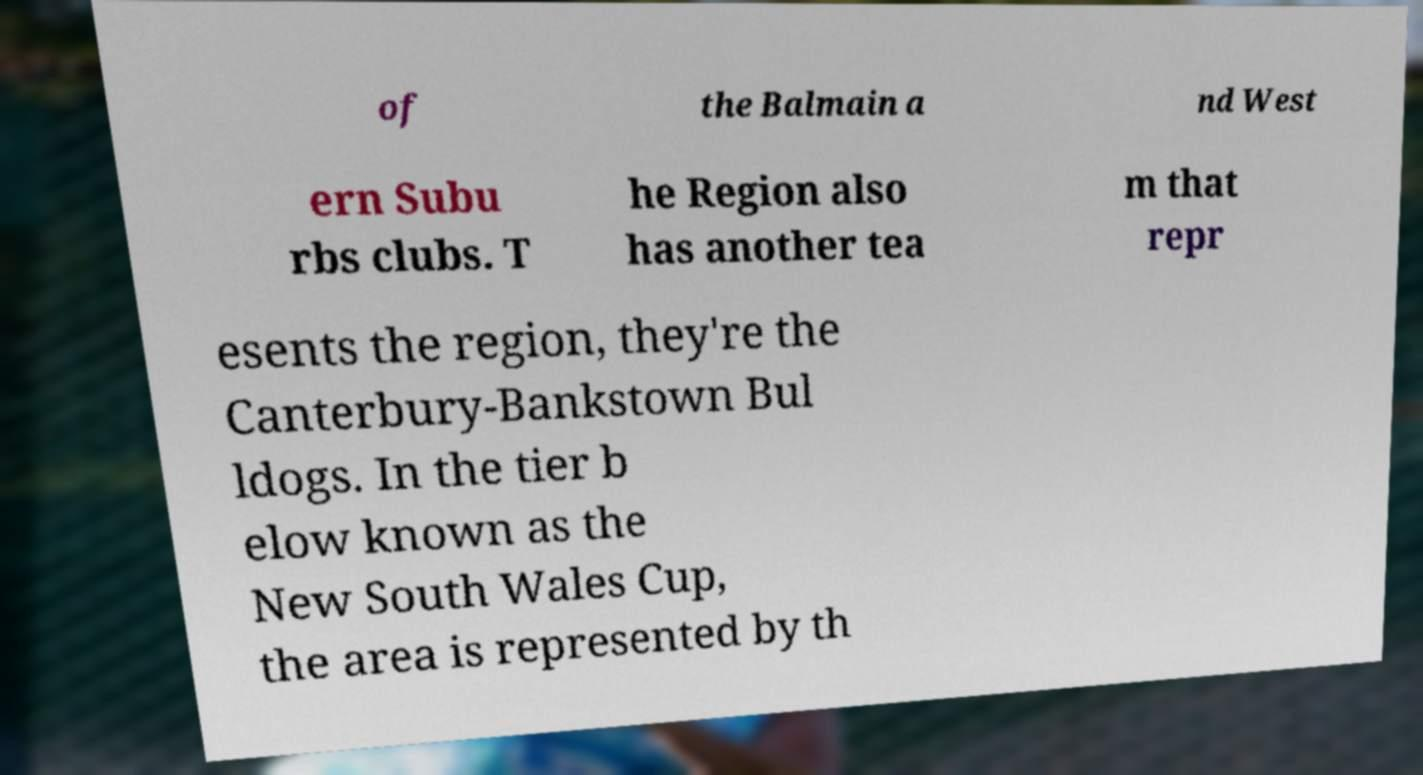Can you read and provide the text displayed in the image?This photo seems to have some interesting text. Can you extract and type it out for me? of the Balmain a nd West ern Subu rbs clubs. T he Region also has another tea m that repr esents the region, they're the Canterbury-Bankstown Bul ldogs. In the tier b elow known as the New South Wales Cup, the area is represented by th 